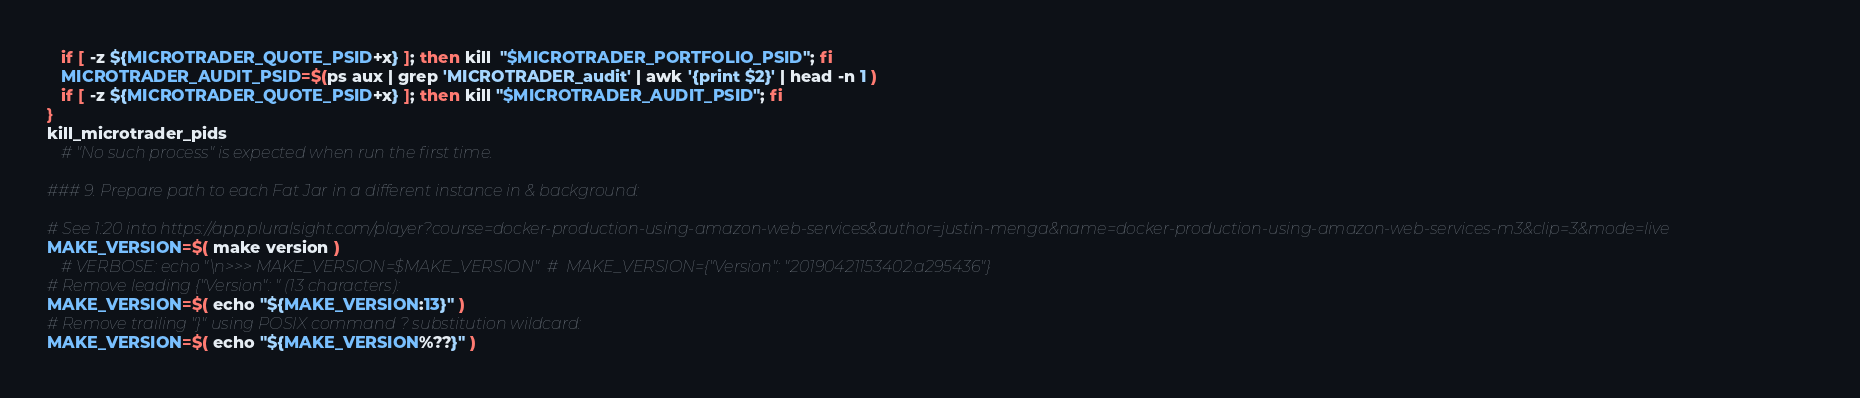<code> <loc_0><loc_0><loc_500><loc_500><_Bash_>   if [ -z ${MICROTRADER_QUOTE_PSID+x} ]; then kill  "$MICROTRADER_PORTFOLIO_PSID"; fi
   MICROTRADER_AUDIT_PSID=$(ps aux | grep 'MICROTRADER_audit' | awk '{print $2}' | head -n 1 )
   if [ -z ${MICROTRADER_QUOTE_PSID+x} ]; then kill "$MICROTRADER_AUDIT_PSID"; fi
}
kill_microtrader_pids
   # "No such process" is expected when run the first time.

### 9. Prepare path to each Fat Jar in a different instance in & background: 

# See 1:20 into https://app.pluralsight.com/player?course=docker-production-using-amazon-web-services&author=justin-menga&name=docker-production-using-amazon-web-services-m3&clip=3&mode=live
MAKE_VERSION=$( make version )
   # VERBOSE: echo "\n>>> MAKE_VERSION=$MAKE_VERSION"  #  MAKE_VERSION={"Version": "20190421153402.a295436"}
# Remove leading {"Version": " (13 characters):
MAKE_VERSION=$( echo "${MAKE_VERSION:13}" )
# Remove trailing "}" using POSIX command ? substitution wildcard:
MAKE_VERSION=$( echo "${MAKE_VERSION%??}" )</code> 